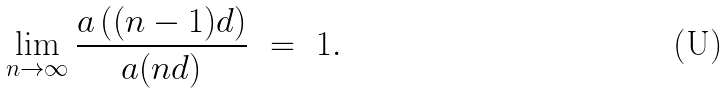<formula> <loc_0><loc_0><loc_500><loc_500>\lim _ { n \rightarrow \infty } \frac { a \left ( ( n - 1 ) d \right ) } { a ( n d ) } \ = \ 1 .</formula> 